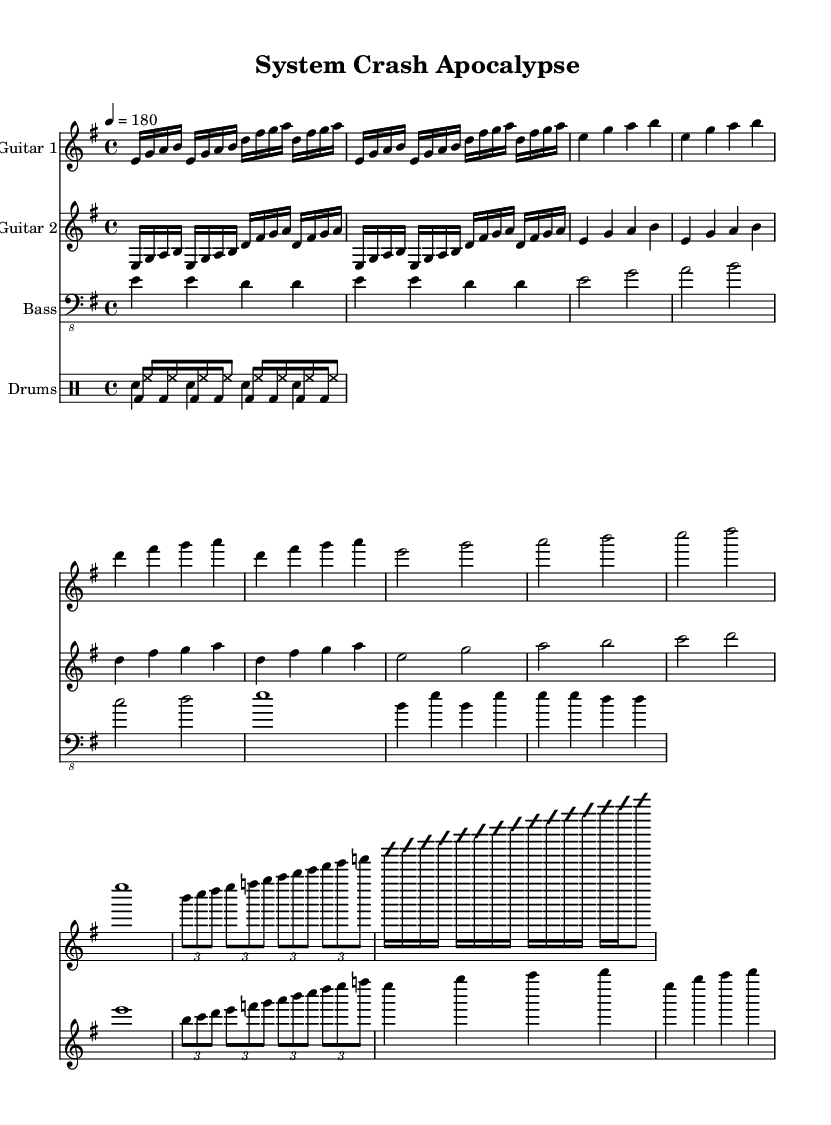What is the key signature of this music? The key signature is E minor, which has one sharp (F#). It can be identified in the beginning of the sheet music, just after the clef and before the time signature.
Answer: E minor What is the time signature of this music? The time signature is 4/4, which indicates that there are four beats in each measure. This is seen right after the key signature in the sheet music.
Answer: 4/4 What is the tempo marking for this piece? The tempo marking is 4 = 180, which means there are 180 beats per minute, with each quarter note receiving one beat. This is indicated in the tempo section of the header in the sheet music.
Answer: 180 How many measures does the main riff repeat? The main riff repeats twice, as shown with the repeat sign placed before the intro section. The notation clearly indicates that the section is to be played two times.
Answer: 2 What is the primary theme of the song? The primary theme centers around the idea of technological failures and digital disasters, depicted through aggressive guitar riffs and rhythmic motifs typical of thrash metal. The lyrics and title suggest this theme, and the music composition aligns with it.
Answer: Technological failures Which instrument plays the solo? The instrument that plays the solo is Guitar 1. This is indicated by the improvisation markings and the placement of notes within the guitar part, specifically denoting where the solo occurs.
Answer: Guitar 1 What type of rhythm section is used in this song? The rhythm section consists of bass guitar and drums, providing a solid underpinning for the guitar parts. The sheet music has specific notations for bass and drums, emphasizing their roles in driving the song forward.
Answer: Bass and drums 